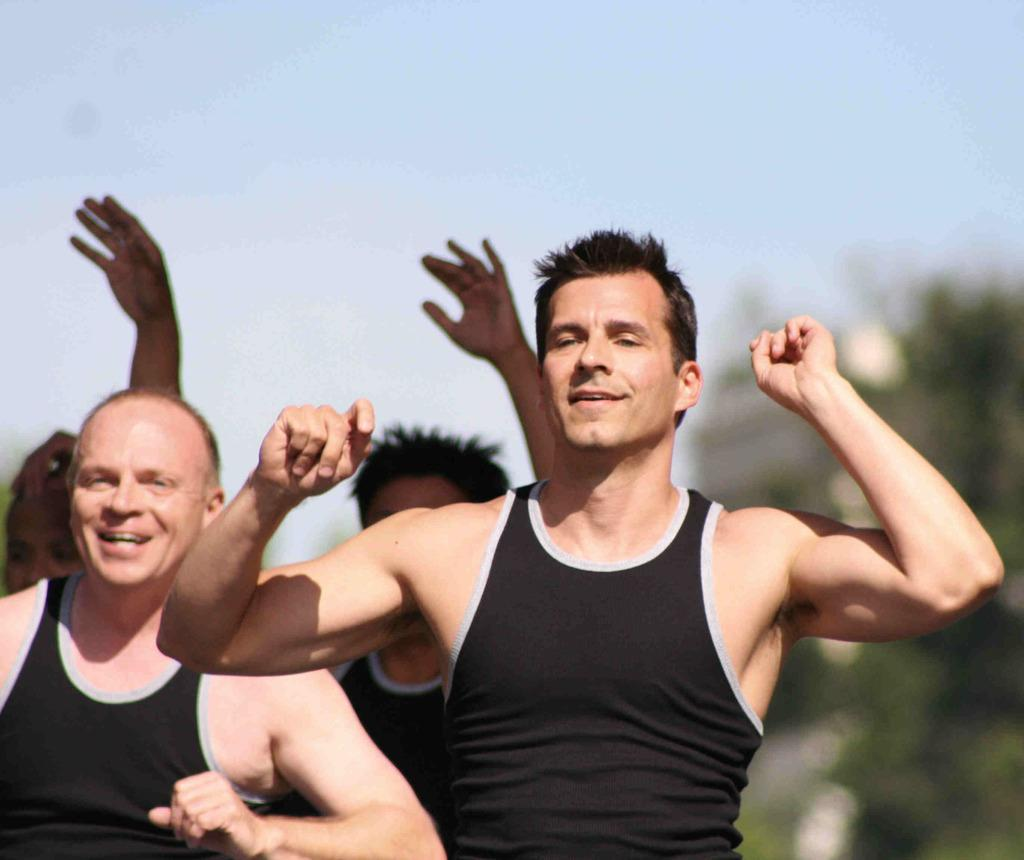How many people are in the image? There are two persons in the image. What are the people wearing? Both persons are wearing black colored dresses. What are the people doing in the image? The two persons are standing. Can you describe the background of the image? There are other persons, trees, and the sky visible in the background of the image. What type of clock can be seen hanging from the tree in the background? There is no clock visible in the image, and no clock is hanging from a tree in the background. 